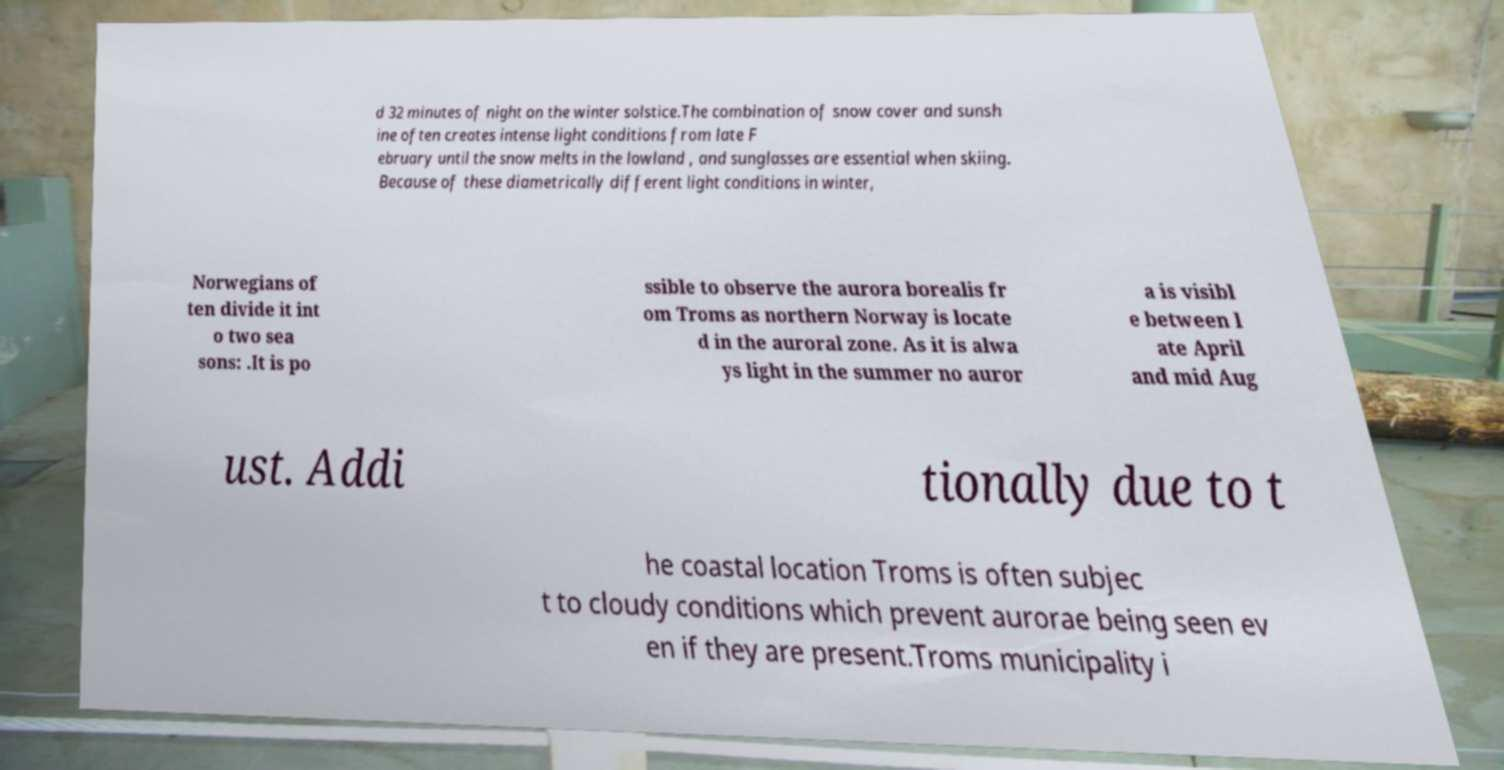Could you assist in decoding the text presented in this image and type it out clearly? d 32 minutes of night on the winter solstice.The combination of snow cover and sunsh ine often creates intense light conditions from late F ebruary until the snow melts in the lowland , and sunglasses are essential when skiing. Because of these diametrically different light conditions in winter, Norwegians of ten divide it int o two sea sons: .It is po ssible to observe the aurora borealis fr om Troms as northern Norway is locate d in the auroral zone. As it is alwa ys light in the summer no auror a is visibl e between l ate April and mid Aug ust. Addi tionally due to t he coastal location Troms is often subjec t to cloudy conditions which prevent aurorae being seen ev en if they are present.Troms municipality i 